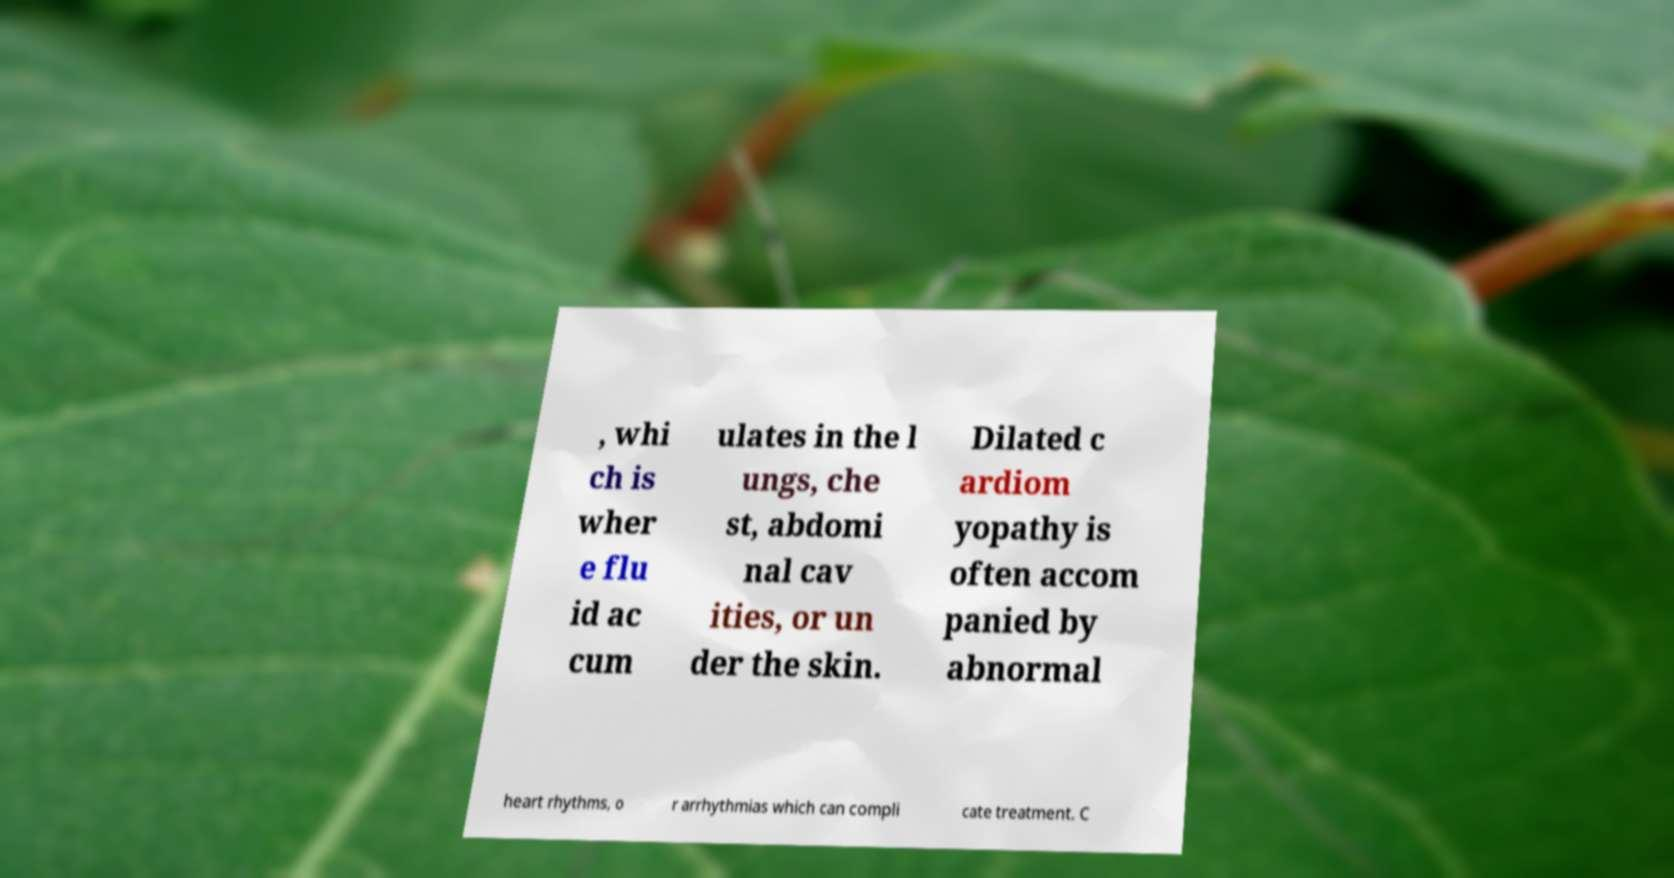Can you read and provide the text displayed in the image?This photo seems to have some interesting text. Can you extract and type it out for me? , whi ch is wher e flu id ac cum ulates in the l ungs, che st, abdomi nal cav ities, or un der the skin. Dilated c ardiom yopathy is often accom panied by abnormal heart rhythms, o r arrhythmias which can compli cate treatment. C 